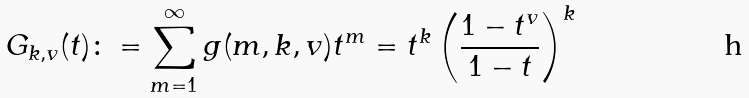<formula> <loc_0><loc_0><loc_500><loc_500>G _ { k , v } ( t ) \colon = \sum _ { m = 1 } ^ { \infty } g ( m , k , v ) t ^ { m } = t ^ { k } \left ( \frac { 1 - t ^ { v } } { 1 - t } \right ) ^ { k }</formula> 